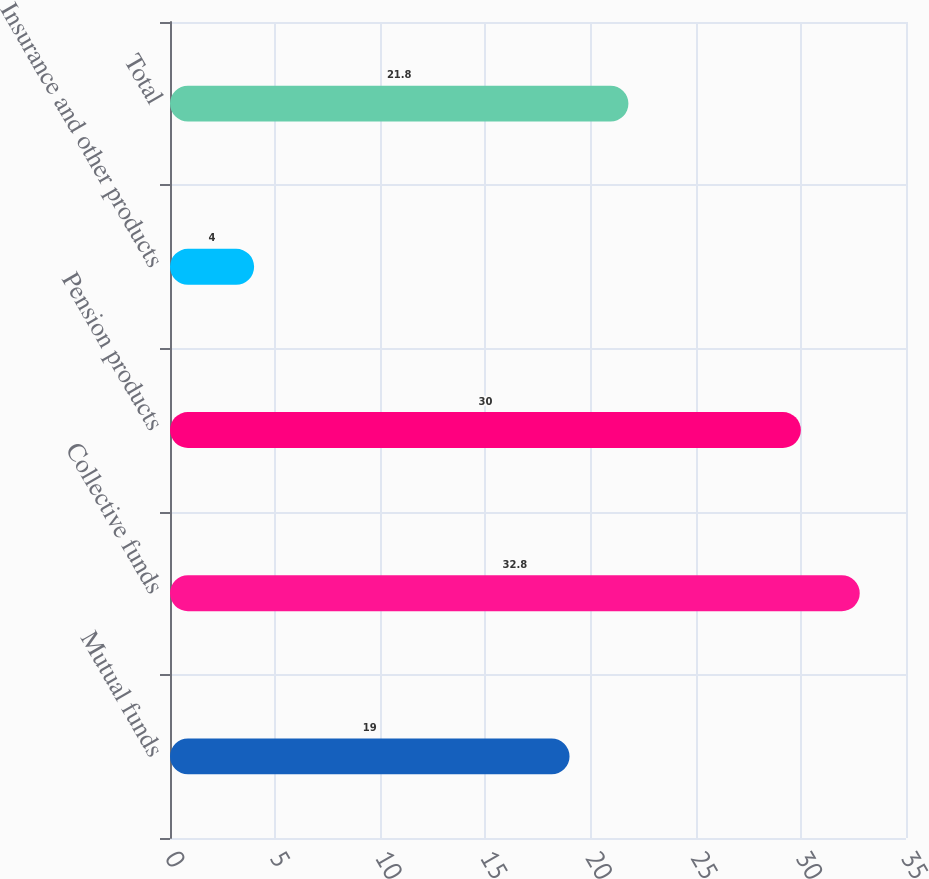Convert chart. <chart><loc_0><loc_0><loc_500><loc_500><bar_chart><fcel>Mutual funds<fcel>Collective funds<fcel>Pension products<fcel>Insurance and other products<fcel>Total<nl><fcel>19<fcel>32.8<fcel>30<fcel>4<fcel>21.8<nl></chart> 